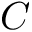<formula> <loc_0><loc_0><loc_500><loc_500>C</formula> 